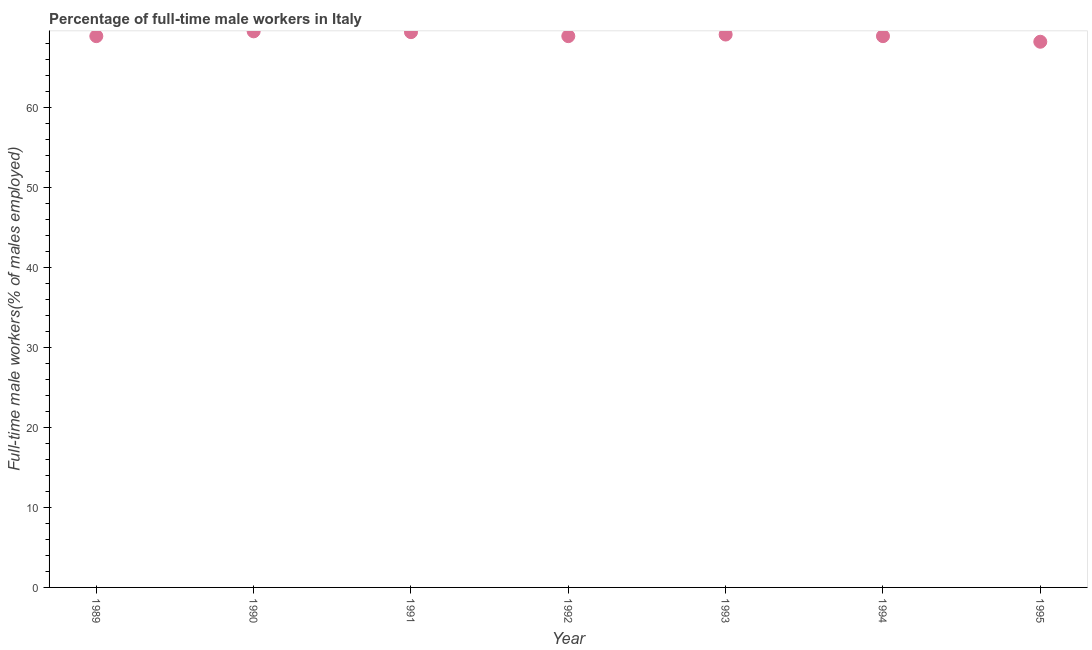What is the percentage of full-time male workers in 1995?
Make the answer very short. 68.2. Across all years, what is the maximum percentage of full-time male workers?
Your response must be concise. 69.5. Across all years, what is the minimum percentage of full-time male workers?
Offer a very short reply. 68.2. In which year was the percentage of full-time male workers minimum?
Offer a very short reply. 1995. What is the sum of the percentage of full-time male workers?
Your response must be concise. 482.9. What is the difference between the percentage of full-time male workers in 1990 and 1992?
Provide a succinct answer. 0.6. What is the average percentage of full-time male workers per year?
Ensure brevity in your answer.  68.99. What is the median percentage of full-time male workers?
Give a very brief answer. 68.9. What is the ratio of the percentage of full-time male workers in 1991 to that in 1992?
Your response must be concise. 1.01. Is the difference between the percentage of full-time male workers in 1989 and 1995 greater than the difference between any two years?
Make the answer very short. No. What is the difference between the highest and the second highest percentage of full-time male workers?
Ensure brevity in your answer.  0.1. Is the sum of the percentage of full-time male workers in 1990 and 1995 greater than the maximum percentage of full-time male workers across all years?
Offer a very short reply. Yes. What is the difference between the highest and the lowest percentage of full-time male workers?
Your response must be concise. 1.3. In how many years, is the percentage of full-time male workers greater than the average percentage of full-time male workers taken over all years?
Keep it short and to the point. 3. How many years are there in the graph?
Offer a terse response. 7. What is the difference between two consecutive major ticks on the Y-axis?
Your answer should be very brief. 10. What is the title of the graph?
Provide a short and direct response. Percentage of full-time male workers in Italy. What is the label or title of the Y-axis?
Your answer should be compact. Full-time male workers(% of males employed). What is the Full-time male workers(% of males employed) in 1989?
Offer a terse response. 68.9. What is the Full-time male workers(% of males employed) in 1990?
Offer a terse response. 69.5. What is the Full-time male workers(% of males employed) in 1991?
Give a very brief answer. 69.4. What is the Full-time male workers(% of males employed) in 1992?
Provide a short and direct response. 68.9. What is the Full-time male workers(% of males employed) in 1993?
Your response must be concise. 69.1. What is the Full-time male workers(% of males employed) in 1994?
Your answer should be very brief. 68.9. What is the Full-time male workers(% of males employed) in 1995?
Provide a succinct answer. 68.2. What is the difference between the Full-time male workers(% of males employed) in 1989 and 1990?
Ensure brevity in your answer.  -0.6. What is the difference between the Full-time male workers(% of males employed) in 1990 and 1991?
Provide a short and direct response. 0.1. What is the difference between the Full-time male workers(% of males employed) in 1990 and 1992?
Your answer should be very brief. 0.6. What is the difference between the Full-time male workers(% of males employed) in 1990 and 1994?
Ensure brevity in your answer.  0.6. What is the difference between the Full-time male workers(% of males employed) in 1991 and 1993?
Your answer should be very brief. 0.3. What is the difference between the Full-time male workers(% of males employed) in 1991 and 1994?
Your answer should be compact. 0.5. What is the difference between the Full-time male workers(% of males employed) in 1992 and 1993?
Your answer should be compact. -0.2. What is the difference between the Full-time male workers(% of males employed) in 1993 and 1995?
Provide a succinct answer. 0.9. What is the ratio of the Full-time male workers(% of males employed) in 1989 to that in 1991?
Make the answer very short. 0.99. What is the ratio of the Full-time male workers(% of males employed) in 1989 to that in 1994?
Provide a succinct answer. 1. What is the ratio of the Full-time male workers(% of males employed) in 1991 to that in 1993?
Ensure brevity in your answer.  1. What is the ratio of the Full-time male workers(% of males employed) in 1991 to that in 1994?
Offer a very short reply. 1.01. What is the ratio of the Full-time male workers(% of males employed) in 1992 to that in 1993?
Your answer should be compact. 1. What is the ratio of the Full-time male workers(% of males employed) in 1993 to that in 1994?
Offer a terse response. 1. 